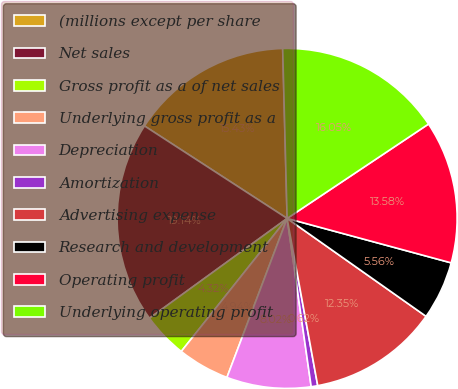<chart> <loc_0><loc_0><loc_500><loc_500><pie_chart><fcel>(millions except per share<fcel>Net sales<fcel>Gross profit as a of net sales<fcel>Underlying gross profit as a<fcel>Depreciation<fcel>Amortization<fcel>Advertising expense<fcel>Research and development<fcel>Operating profit<fcel>Underlying operating profit<nl><fcel>15.43%<fcel>19.14%<fcel>4.32%<fcel>4.94%<fcel>8.02%<fcel>0.62%<fcel>12.35%<fcel>5.56%<fcel>13.58%<fcel>16.05%<nl></chart> 